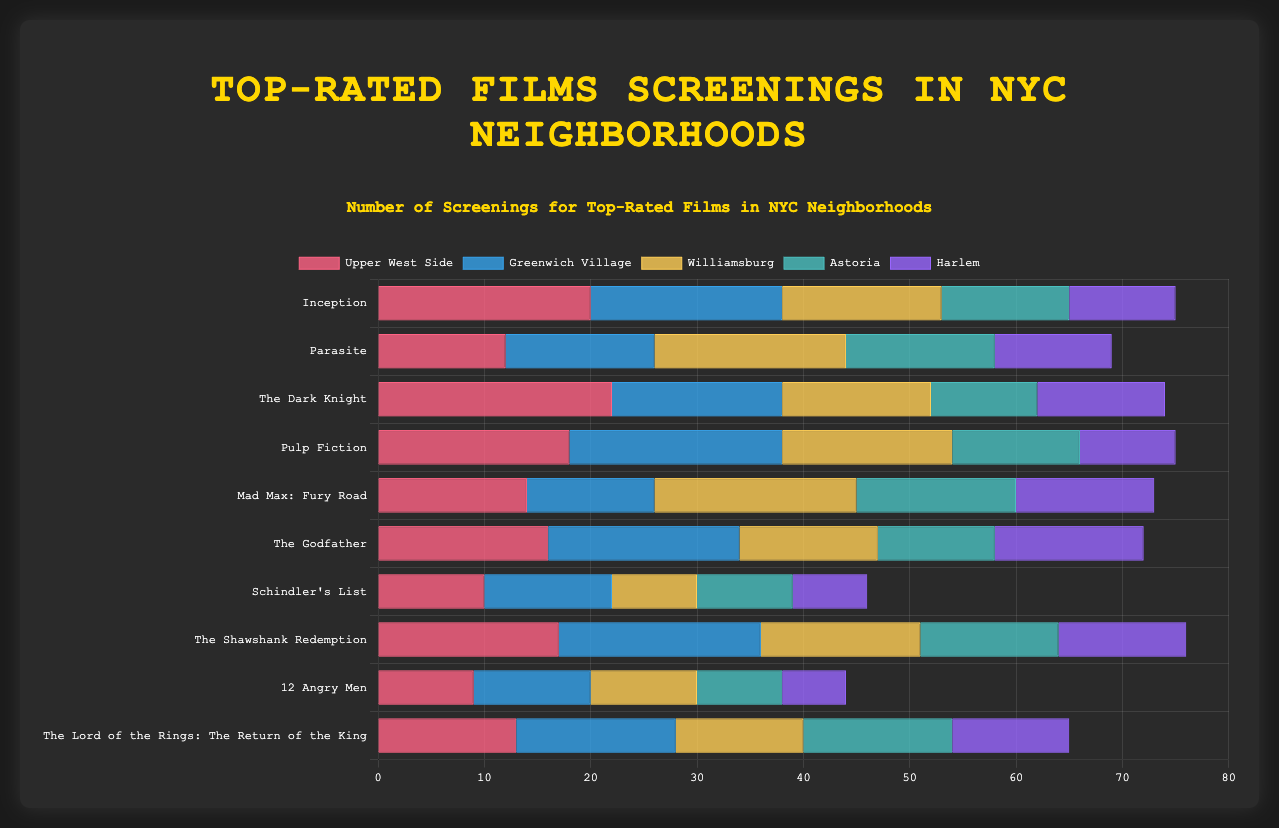Which film has the highest number of screenings in Upper West Side? Scan the graph for the "Upper West Side" section and find the longest bar. The longest bar corresponds to "The Dark Knight" with 22 screenings.
Answer: The Dark Knight Compare the total screenings of "Inception" in all neighborhoods to "Pulp Fiction" in all neighborhoods. Which film has more total screenings? Sum the screenings for "Inception" (20 + 18 + 15 + 12 + 10 = 75) and "Pulp Fiction" (18 + 20 + 16 + 12 + 9 = 75). Since both sums are equal, both films have the same total screenings.
Answer: Both Which neighborhood has the fewest screenings for "Schindler's List"? Look for the shortest bar in the "Schindler's List" category. The shortest bar is for "Harlem" with 7 screenings.
Answer: Harlem What's the average number of screenings for "Parasite" across all neighborhoods? Sum the screenings for "Parasite" (12 + 14 + 18 + 14 + 11 = 69) and divide by the number of neighborhoods (5). The average is 69 / 5 = 13.8.
Answer: 13.8 Between "Williamsburg" and "Astoria," which neighborhood has more screenings for "The Shawshank Redemption"? Compare the bars for "The Shawshank Redemption" in Williamsburg (15) and Astoria (13). Williamsburg has more screenings.
Answer: Williamsburg How many more screenings does "The Dark Knight" have in Upper West Side compared to Harlem? Subtract Harlem's screenings (12) from Upper West Side's screenings (22). The difference is 22 - 12 = 10 screenings.
Answer: 10 Which film has the least number of screenings in Greenwich Village? Look for the shortest bar in the "Greenwich Village" section. The shortest bar is for "12 Angry Men" with 11 screenings.
Answer: 12 Angry Men In which neighborhood does "The Godfather" have the highest number of screenings? Look at the "The Godfather" bars and find the longest one. The longest bar is for "Greenwich Village" with 18 screenings.
Answer: Greenwich Village Rank the neighborhoods by the number of screenings of "Mad Max: Fury Road" in descending order. Order the bars for "Mad Max: Fury Road" by their lengths: Williamsburg (19), Astoria (15), Harlem (13), Upper West Side (14), Greenwich Village (12). The descending order is Williamsburg, Astoria, Upper West Side, Harlem, Greenwich Village.
Answer: Williamsburg, Astoria, Upper West Side, Harlem, Greenwich Village Which film has the most consistent number of screenings across all neighborhoods (least variation)? Calculate the range (max - min) for each film’s screenings across neighborhoods: 
Inception (20-10=10), 
Parasite (18-11=7), 
The Dark Knight (22-10=12), 
Pulp Fiction (20-9=11), 
Mad Max: Fury Road (19-12=7), 
The Godfather (18-11=7), 
Schindler's List (12-7=5), 
The Shawshank Redemption (19-12=7), 
12 Angry Men (11-6=5), 
The Lord of the Rings: The Return of the King (15-11=4). 
The film with the smallest range is "The Lord of the Rings: The Return of the King" with a range of 4.
Answer: The Lord of the Rings: The Return of the King 